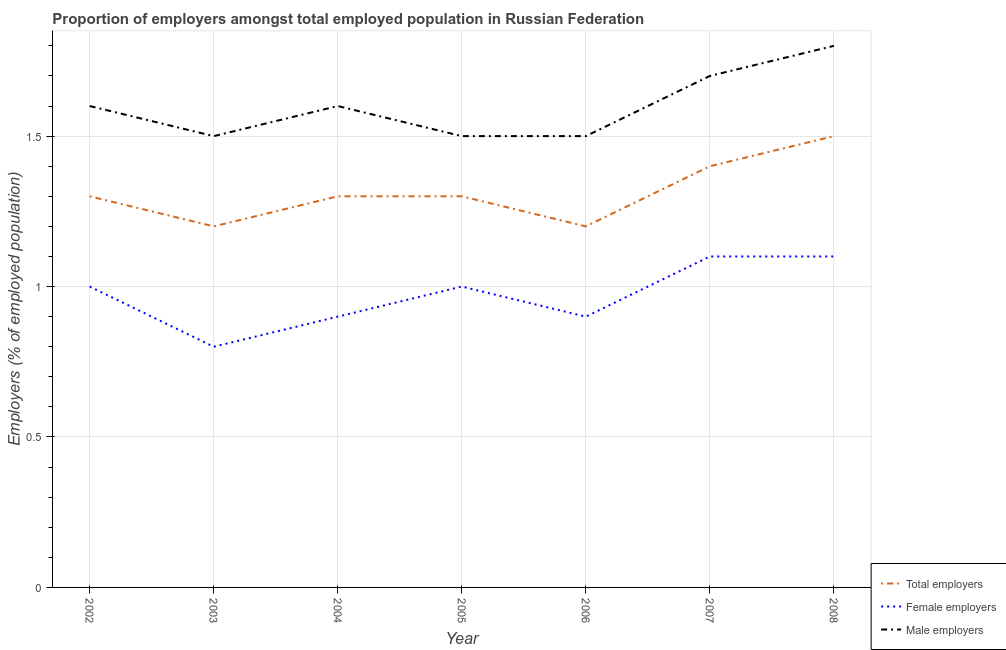How many different coloured lines are there?
Provide a succinct answer. 3. Does the line corresponding to percentage of female employers intersect with the line corresponding to percentage of male employers?
Your answer should be very brief. No. Is the number of lines equal to the number of legend labels?
Provide a succinct answer. Yes. What is the percentage of female employers in 2008?
Provide a succinct answer. 1.1. Across all years, what is the minimum percentage of total employers?
Offer a terse response. 1.2. In which year was the percentage of female employers maximum?
Your answer should be very brief. 2007. In which year was the percentage of total employers minimum?
Your response must be concise. 2003. What is the total percentage of male employers in the graph?
Your answer should be compact. 11.2. What is the difference between the percentage of male employers in 2002 and that in 2003?
Keep it short and to the point. 0.1. What is the difference between the percentage of female employers in 2007 and the percentage of male employers in 2005?
Provide a succinct answer. -0.4. What is the average percentage of male employers per year?
Keep it short and to the point. 1.6. In the year 2005, what is the difference between the percentage of female employers and percentage of male employers?
Your response must be concise. -0.5. In how many years, is the percentage of male employers greater than 1.3 %?
Your answer should be compact. 7. What is the ratio of the percentage of male employers in 2005 to that in 2006?
Ensure brevity in your answer.  1. Is the difference between the percentage of male employers in 2003 and 2005 greater than the difference between the percentage of female employers in 2003 and 2005?
Make the answer very short. Yes. What is the difference between the highest and the second highest percentage of female employers?
Offer a very short reply. 0. What is the difference between the highest and the lowest percentage of total employers?
Your answer should be very brief. 0.3. In how many years, is the percentage of total employers greater than the average percentage of total employers taken over all years?
Give a very brief answer. 2. Is the sum of the percentage of male employers in 2003 and 2005 greater than the maximum percentage of total employers across all years?
Make the answer very short. Yes. Is it the case that in every year, the sum of the percentage of total employers and percentage of female employers is greater than the percentage of male employers?
Keep it short and to the point. Yes. Does the percentage of total employers monotonically increase over the years?
Your response must be concise. No. Is the percentage of total employers strictly greater than the percentage of female employers over the years?
Give a very brief answer. Yes. Is the percentage of female employers strictly less than the percentage of total employers over the years?
Offer a terse response. Yes. What is the difference between two consecutive major ticks on the Y-axis?
Make the answer very short. 0.5. Are the values on the major ticks of Y-axis written in scientific E-notation?
Ensure brevity in your answer.  No. Where does the legend appear in the graph?
Give a very brief answer. Bottom right. How are the legend labels stacked?
Your response must be concise. Vertical. What is the title of the graph?
Your answer should be very brief. Proportion of employers amongst total employed population in Russian Federation. Does "Poland" appear as one of the legend labels in the graph?
Your answer should be compact. No. What is the label or title of the X-axis?
Provide a succinct answer. Year. What is the label or title of the Y-axis?
Offer a very short reply. Employers (% of employed population). What is the Employers (% of employed population) of Total employers in 2002?
Provide a succinct answer. 1.3. What is the Employers (% of employed population) in Female employers in 2002?
Keep it short and to the point. 1. What is the Employers (% of employed population) of Male employers in 2002?
Provide a succinct answer. 1.6. What is the Employers (% of employed population) in Total employers in 2003?
Offer a terse response. 1.2. What is the Employers (% of employed population) of Female employers in 2003?
Keep it short and to the point. 0.8. What is the Employers (% of employed population) of Total employers in 2004?
Offer a terse response. 1.3. What is the Employers (% of employed population) of Female employers in 2004?
Keep it short and to the point. 0.9. What is the Employers (% of employed population) of Male employers in 2004?
Make the answer very short. 1.6. What is the Employers (% of employed population) of Total employers in 2005?
Your answer should be very brief. 1.3. What is the Employers (% of employed population) of Female employers in 2005?
Your answer should be very brief. 1. What is the Employers (% of employed population) of Total employers in 2006?
Give a very brief answer. 1.2. What is the Employers (% of employed population) in Female employers in 2006?
Your answer should be very brief. 0.9. What is the Employers (% of employed population) in Male employers in 2006?
Keep it short and to the point. 1.5. What is the Employers (% of employed population) of Total employers in 2007?
Keep it short and to the point. 1.4. What is the Employers (% of employed population) in Female employers in 2007?
Offer a terse response. 1.1. What is the Employers (% of employed population) in Male employers in 2007?
Provide a succinct answer. 1.7. What is the Employers (% of employed population) in Total employers in 2008?
Make the answer very short. 1.5. What is the Employers (% of employed population) of Female employers in 2008?
Offer a very short reply. 1.1. What is the Employers (% of employed population) of Male employers in 2008?
Offer a terse response. 1.8. Across all years, what is the maximum Employers (% of employed population) in Female employers?
Offer a very short reply. 1.1. Across all years, what is the maximum Employers (% of employed population) in Male employers?
Offer a very short reply. 1.8. Across all years, what is the minimum Employers (% of employed population) in Total employers?
Your response must be concise. 1.2. Across all years, what is the minimum Employers (% of employed population) of Female employers?
Provide a short and direct response. 0.8. What is the difference between the Employers (% of employed population) in Male employers in 2002 and that in 2003?
Give a very brief answer. 0.1. What is the difference between the Employers (% of employed population) in Total employers in 2002 and that in 2004?
Give a very brief answer. 0. What is the difference between the Employers (% of employed population) in Male employers in 2002 and that in 2004?
Your answer should be compact. 0. What is the difference between the Employers (% of employed population) of Female employers in 2002 and that in 2005?
Ensure brevity in your answer.  0. What is the difference between the Employers (% of employed population) in Total employers in 2002 and that in 2006?
Your answer should be very brief. 0.1. What is the difference between the Employers (% of employed population) in Female employers in 2002 and that in 2006?
Offer a very short reply. 0.1. What is the difference between the Employers (% of employed population) of Male employers in 2002 and that in 2006?
Provide a succinct answer. 0.1. What is the difference between the Employers (% of employed population) in Total employers in 2002 and that in 2008?
Your response must be concise. -0.2. What is the difference between the Employers (% of employed population) of Male employers in 2003 and that in 2004?
Offer a terse response. -0.1. What is the difference between the Employers (% of employed population) in Female employers in 2003 and that in 2005?
Offer a very short reply. -0.2. What is the difference between the Employers (% of employed population) in Male employers in 2003 and that in 2005?
Your answer should be compact. 0. What is the difference between the Employers (% of employed population) of Total employers in 2003 and that in 2006?
Offer a terse response. 0. What is the difference between the Employers (% of employed population) in Female employers in 2003 and that in 2006?
Make the answer very short. -0.1. What is the difference between the Employers (% of employed population) in Male employers in 2003 and that in 2006?
Offer a terse response. 0. What is the difference between the Employers (% of employed population) in Total employers in 2003 and that in 2007?
Your answer should be very brief. -0.2. What is the difference between the Employers (% of employed population) in Male employers in 2003 and that in 2007?
Provide a short and direct response. -0.2. What is the difference between the Employers (% of employed population) in Female employers in 2004 and that in 2006?
Your answer should be compact. 0. What is the difference between the Employers (% of employed population) in Total employers in 2004 and that in 2007?
Ensure brevity in your answer.  -0.1. What is the difference between the Employers (% of employed population) in Male employers in 2004 and that in 2007?
Offer a very short reply. -0.1. What is the difference between the Employers (% of employed population) in Male employers in 2004 and that in 2008?
Offer a very short reply. -0.2. What is the difference between the Employers (% of employed population) in Male employers in 2005 and that in 2006?
Ensure brevity in your answer.  0. What is the difference between the Employers (% of employed population) in Total employers in 2005 and that in 2007?
Provide a succinct answer. -0.1. What is the difference between the Employers (% of employed population) in Male employers in 2005 and that in 2008?
Keep it short and to the point. -0.3. What is the difference between the Employers (% of employed population) in Female employers in 2006 and that in 2007?
Provide a succinct answer. -0.2. What is the difference between the Employers (% of employed population) in Male employers in 2007 and that in 2008?
Provide a short and direct response. -0.1. What is the difference between the Employers (% of employed population) of Total employers in 2002 and the Employers (% of employed population) of Female employers in 2003?
Offer a very short reply. 0.5. What is the difference between the Employers (% of employed population) of Total employers in 2002 and the Employers (% of employed population) of Male employers in 2003?
Your answer should be compact. -0.2. What is the difference between the Employers (% of employed population) in Female employers in 2002 and the Employers (% of employed population) in Male employers in 2003?
Offer a terse response. -0.5. What is the difference between the Employers (% of employed population) in Female employers in 2002 and the Employers (% of employed population) in Male employers in 2004?
Provide a short and direct response. -0.6. What is the difference between the Employers (% of employed population) in Total employers in 2002 and the Employers (% of employed population) in Male employers in 2005?
Keep it short and to the point. -0.2. What is the difference between the Employers (% of employed population) in Total employers in 2002 and the Employers (% of employed population) in Male employers in 2006?
Your answer should be compact. -0.2. What is the difference between the Employers (% of employed population) in Female employers in 2002 and the Employers (% of employed population) in Male employers in 2006?
Offer a terse response. -0.5. What is the difference between the Employers (% of employed population) of Female employers in 2002 and the Employers (% of employed population) of Male employers in 2007?
Provide a short and direct response. -0.7. What is the difference between the Employers (% of employed population) of Total employers in 2002 and the Employers (% of employed population) of Female employers in 2008?
Offer a very short reply. 0.2. What is the difference between the Employers (% of employed population) of Total employers in 2002 and the Employers (% of employed population) of Male employers in 2008?
Ensure brevity in your answer.  -0.5. What is the difference between the Employers (% of employed population) in Female employers in 2002 and the Employers (% of employed population) in Male employers in 2008?
Provide a succinct answer. -0.8. What is the difference between the Employers (% of employed population) in Total employers in 2003 and the Employers (% of employed population) in Male employers in 2004?
Give a very brief answer. -0.4. What is the difference between the Employers (% of employed population) in Total employers in 2003 and the Employers (% of employed population) in Male employers in 2005?
Offer a terse response. -0.3. What is the difference between the Employers (% of employed population) of Total employers in 2003 and the Employers (% of employed population) of Female employers in 2006?
Your response must be concise. 0.3. What is the difference between the Employers (% of employed population) in Total employers in 2003 and the Employers (% of employed population) in Male employers in 2006?
Provide a short and direct response. -0.3. What is the difference between the Employers (% of employed population) in Total employers in 2003 and the Employers (% of employed population) in Female employers in 2007?
Provide a succinct answer. 0.1. What is the difference between the Employers (% of employed population) in Total employers in 2003 and the Employers (% of employed population) in Male employers in 2007?
Ensure brevity in your answer.  -0.5. What is the difference between the Employers (% of employed population) in Female employers in 2003 and the Employers (% of employed population) in Male employers in 2007?
Keep it short and to the point. -0.9. What is the difference between the Employers (% of employed population) in Total employers in 2003 and the Employers (% of employed population) in Female employers in 2008?
Give a very brief answer. 0.1. What is the difference between the Employers (% of employed population) in Total employers in 2003 and the Employers (% of employed population) in Male employers in 2008?
Provide a short and direct response. -0.6. What is the difference between the Employers (% of employed population) of Female employers in 2003 and the Employers (% of employed population) of Male employers in 2008?
Provide a short and direct response. -1. What is the difference between the Employers (% of employed population) in Total employers in 2004 and the Employers (% of employed population) in Female employers in 2005?
Provide a succinct answer. 0.3. What is the difference between the Employers (% of employed population) of Total employers in 2004 and the Employers (% of employed population) of Male employers in 2005?
Keep it short and to the point. -0.2. What is the difference between the Employers (% of employed population) in Total employers in 2004 and the Employers (% of employed population) in Female employers in 2006?
Offer a terse response. 0.4. What is the difference between the Employers (% of employed population) in Total employers in 2004 and the Employers (% of employed population) in Female employers in 2008?
Keep it short and to the point. 0.2. What is the difference between the Employers (% of employed population) of Female employers in 2004 and the Employers (% of employed population) of Male employers in 2008?
Keep it short and to the point. -0.9. What is the difference between the Employers (% of employed population) in Total employers in 2005 and the Employers (% of employed population) in Female employers in 2006?
Provide a short and direct response. 0.4. What is the difference between the Employers (% of employed population) in Total employers in 2005 and the Employers (% of employed population) in Male employers in 2006?
Ensure brevity in your answer.  -0.2. What is the difference between the Employers (% of employed population) in Female employers in 2005 and the Employers (% of employed population) in Male employers in 2006?
Provide a succinct answer. -0.5. What is the difference between the Employers (% of employed population) in Total employers in 2005 and the Employers (% of employed population) in Female employers in 2008?
Your response must be concise. 0.2. What is the difference between the Employers (% of employed population) of Total employers in 2005 and the Employers (% of employed population) of Male employers in 2008?
Offer a terse response. -0.5. What is the difference between the Employers (% of employed population) of Female employers in 2005 and the Employers (% of employed population) of Male employers in 2008?
Your answer should be very brief. -0.8. What is the difference between the Employers (% of employed population) of Total employers in 2006 and the Employers (% of employed population) of Male employers in 2007?
Provide a succinct answer. -0.5. What is the difference between the Employers (% of employed population) of Total employers in 2006 and the Employers (% of employed population) of Female employers in 2008?
Your answer should be compact. 0.1. What is the difference between the Employers (% of employed population) in Total employers in 2006 and the Employers (% of employed population) in Male employers in 2008?
Make the answer very short. -0.6. What is the difference between the Employers (% of employed population) of Total employers in 2007 and the Employers (% of employed population) of Male employers in 2008?
Your answer should be compact. -0.4. What is the average Employers (% of employed population) of Total employers per year?
Ensure brevity in your answer.  1.31. What is the average Employers (% of employed population) of Female employers per year?
Give a very brief answer. 0.97. In the year 2002, what is the difference between the Employers (% of employed population) of Total employers and Employers (% of employed population) of Female employers?
Offer a very short reply. 0.3. In the year 2003, what is the difference between the Employers (% of employed population) of Total employers and Employers (% of employed population) of Female employers?
Give a very brief answer. 0.4. In the year 2003, what is the difference between the Employers (% of employed population) in Female employers and Employers (% of employed population) in Male employers?
Ensure brevity in your answer.  -0.7. In the year 2004, what is the difference between the Employers (% of employed population) of Total employers and Employers (% of employed population) of Female employers?
Make the answer very short. 0.4. In the year 2004, what is the difference between the Employers (% of employed population) of Total employers and Employers (% of employed population) of Male employers?
Ensure brevity in your answer.  -0.3. In the year 2005, what is the difference between the Employers (% of employed population) in Total employers and Employers (% of employed population) in Male employers?
Provide a succinct answer. -0.2. In the year 2006, what is the difference between the Employers (% of employed population) of Total employers and Employers (% of employed population) of Male employers?
Your answer should be very brief. -0.3. In the year 2007, what is the difference between the Employers (% of employed population) of Total employers and Employers (% of employed population) of Female employers?
Make the answer very short. 0.3. In the year 2007, what is the difference between the Employers (% of employed population) in Total employers and Employers (% of employed population) in Male employers?
Your answer should be very brief. -0.3. In the year 2008, what is the difference between the Employers (% of employed population) in Total employers and Employers (% of employed population) in Female employers?
Provide a succinct answer. 0.4. What is the ratio of the Employers (% of employed population) of Male employers in 2002 to that in 2003?
Give a very brief answer. 1.07. What is the ratio of the Employers (% of employed population) in Female employers in 2002 to that in 2004?
Offer a terse response. 1.11. What is the ratio of the Employers (% of employed population) in Male employers in 2002 to that in 2004?
Make the answer very short. 1. What is the ratio of the Employers (% of employed population) of Total employers in 2002 to that in 2005?
Your response must be concise. 1. What is the ratio of the Employers (% of employed population) in Male employers in 2002 to that in 2005?
Offer a very short reply. 1.07. What is the ratio of the Employers (% of employed population) of Female employers in 2002 to that in 2006?
Offer a terse response. 1.11. What is the ratio of the Employers (% of employed population) of Male employers in 2002 to that in 2006?
Your answer should be very brief. 1.07. What is the ratio of the Employers (% of employed population) of Total employers in 2002 to that in 2007?
Make the answer very short. 0.93. What is the ratio of the Employers (% of employed population) of Male employers in 2002 to that in 2007?
Your response must be concise. 0.94. What is the ratio of the Employers (% of employed population) in Total employers in 2002 to that in 2008?
Your answer should be very brief. 0.87. What is the ratio of the Employers (% of employed population) in Female employers in 2002 to that in 2008?
Keep it short and to the point. 0.91. What is the ratio of the Employers (% of employed population) of Male employers in 2002 to that in 2008?
Your response must be concise. 0.89. What is the ratio of the Employers (% of employed population) of Total employers in 2003 to that in 2004?
Ensure brevity in your answer.  0.92. What is the ratio of the Employers (% of employed population) of Female employers in 2003 to that in 2004?
Provide a short and direct response. 0.89. What is the ratio of the Employers (% of employed population) of Male employers in 2003 to that in 2004?
Ensure brevity in your answer.  0.94. What is the ratio of the Employers (% of employed population) of Total employers in 2003 to that in 2005?
Provide a succinct answer. 0.92. What is the ratio of the Employers (% of employed population) in Female employers in 2003 to that in 2005?
Your answer should be compact. 0.8. What is the ratio of the Employers (% of employed population) in Female employers in 2003 to that in 2007?
Your answer should be very brief. 0.73. What is the ratio of the Employers (% of employed population) in Male employers in 2003 to that in 2007?
Your response must be concise. 0.88. What is the ratio of the Employers (% of employed population) in Female employers in 2003 to that in 2008?
Ensure brevity in your answer.  0.73. What is the ratio of the Employers (% of employed population) of Total employers in 2004 to that in 2005?
Your answer should be compact. 1. What is the ratio of the Employers (% of employed population) of Female employers in 2004 to that in 2005?
Offer a terse response. 0.9. What is the ratio of the Employers (% of employed population) in Male employers in 2004 to that in 2005?
Keep it short and to the point. 1.07. What is the ratio of the Employers (% of employed population) in Total employers in 2004 to that in 2006?
Make the answer very short. 1.08. What is the ratio of the Employers (% of employed population) in Female employers in 2004 to that in 2006?
Ensure brevity in your answer.  1. What is the ratio of the Employers (% of employed population) of Male employers in 2004 to that in 2006?
Your answer should be very brief. 1.07. What is the ratio of the Employers (% of employed population) of Female employers in 2004 to that in 2007?
Provide a short and direct response. 0.82. What is the ratio of the Employers (% of employed population) of Male employers in 2004 to that in 2007?
Offer a very short reply. 0.94. What is the ratio of the Employers (% of employed population) in Total employers in 2004 to that in 2008?
Give a very brief answer. 0.87. What is the ratio of the Employers (% of employed population) in Female employers in 2004 to that in 2008?
Offer a terse response. 0.82. What is the ratio of the Employers (% of employed population) of Male employers in 2004 to that in 2008?
Offer a terse response. 0.89. What is the ratio of the Employers (% of employed population) of Female employers in 2005 to that in 2006?
Your answer should be compact. 1.11. What is the ratio of the Employers (% of employed population) of Total employers in 2005 to that in 2007?
Provide a short and direct response. 0.93. What is the ratio of the Employers (% of employed population) in Male employers in 2005 to that in 2007?
Give a very brief answer. 0.88. What is the ratio of the Employers (% of employed population) of Total employers in 2005 to that in 2008?
Ensure brevity in your answer.  0.87. What is the ratio of the Employers (% of employed population) in Female employers in 2005 to that in 2008?
Your answer should be compact. 0.91. What is the ratio of the Employers (% of employed population) in Total employers in 2006 to that in 2007?
Your answer should be compact. 0.86. What is the ratio of the Employers (% of employed population) in Female employers in 2006 to that in 2007?
Ensure brevity in your answer.  0.82. What is the ratio of the Employers (% of employed population) in Male employers in 2006 to that in 2007?
Your answer should be compact. 0.88. What is the ratio of the Employers (% of employed population) in Total employers in 2006 to that in 2008?
Offer a terse response. 0.8. What is the ratio of the Employers (% of employed population) of Female employers in 2006 to that in 2008?
Make the answer very short. 0.82. What is the ratio of the Employers (% of employed population) in Male employers in 2006 to that in 2008?
Your answer should be compact. 0.83. What is the ratio of the Employers (% of employed population) of Female employers in 2007 to that in 2008?
Offer a terse response. 1. What is the difference between the highest and the second highest Employers (% of employed population) of Male employers?
Provide a short and direct response. 0.1. What is the difference between the highest and the lowest Employers (% of employed population) of Total employers?
Your answer should be very brief. 0.3. 